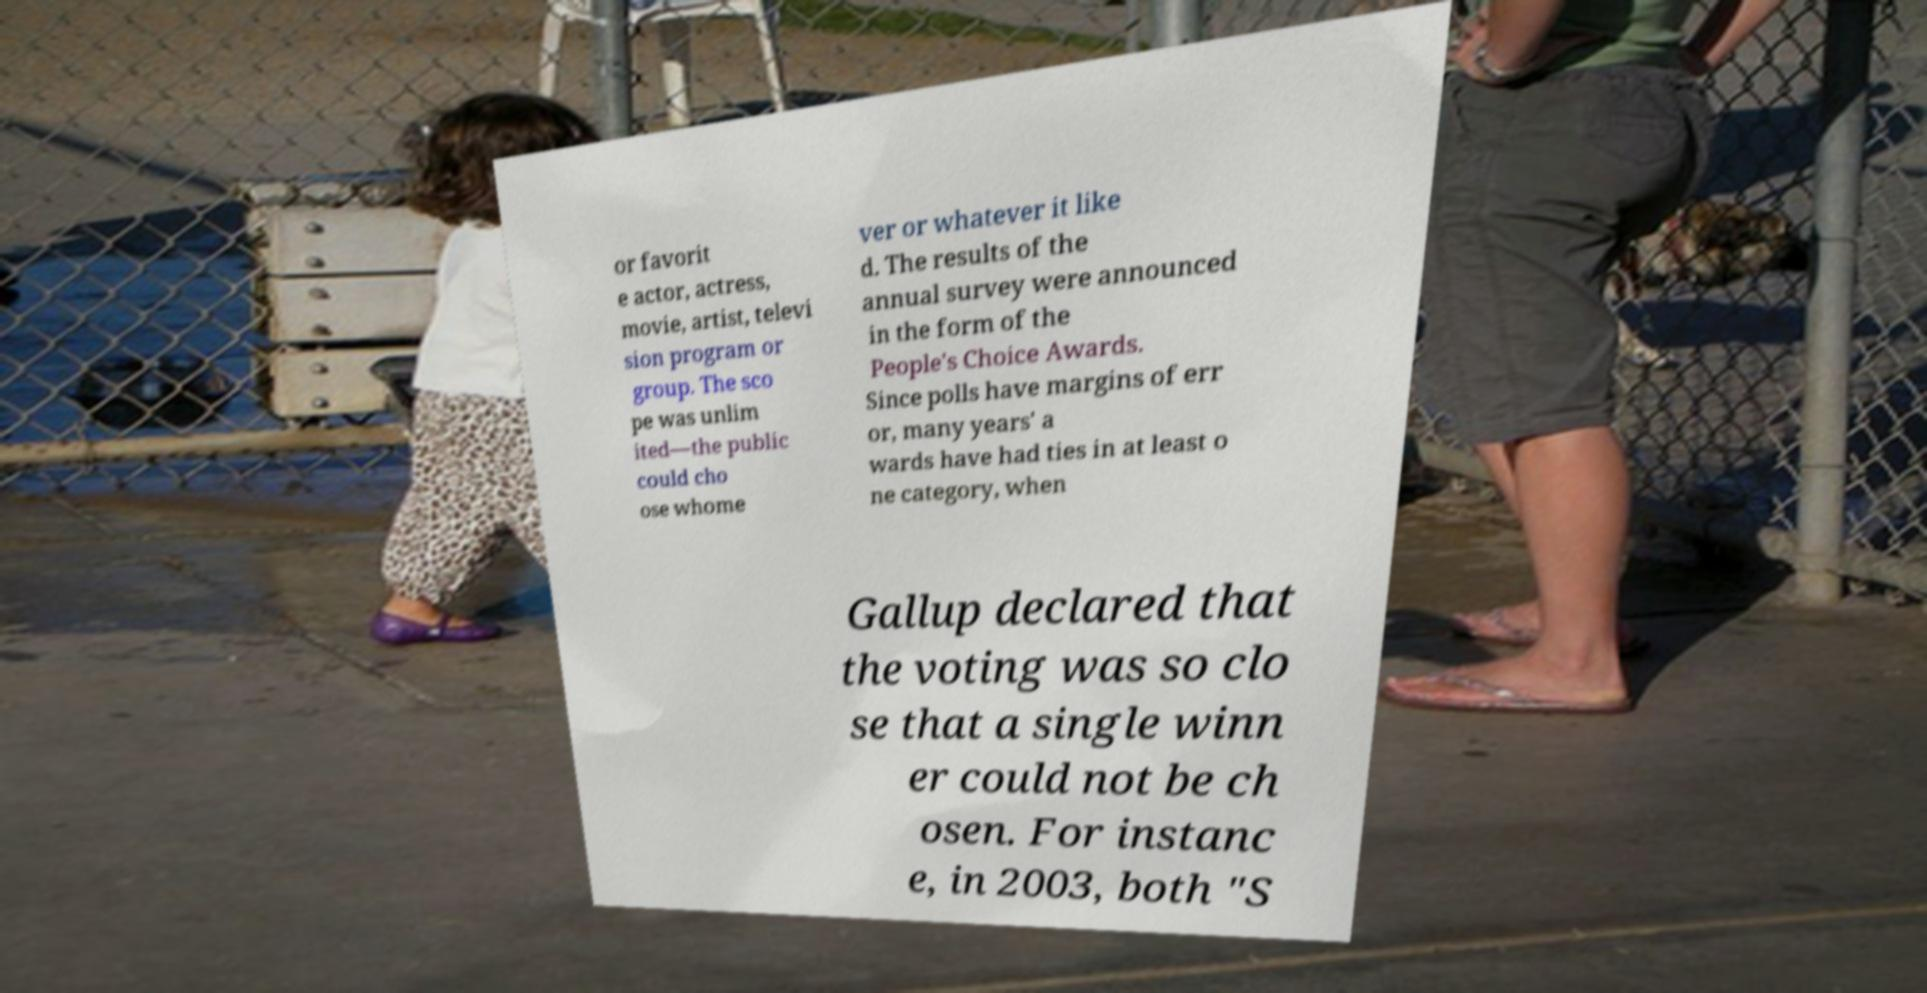Could you assist in decoding the text presented in this image and type it out clearly? or favorit e actor, actress, movie, artist, televi sion program or group. The sco pe was unlim ited—the public could cho ose whome ver or whatever it like d. The results of the annual survey were announced in the form of the People's Choice Awards. Since polls have margins of err or, many years' a wards have had ties in at least o ne category, when Gallup declared that the voting was so clo se that a single winn er could not be ch osen. For instanc e, in 2003, both "S 